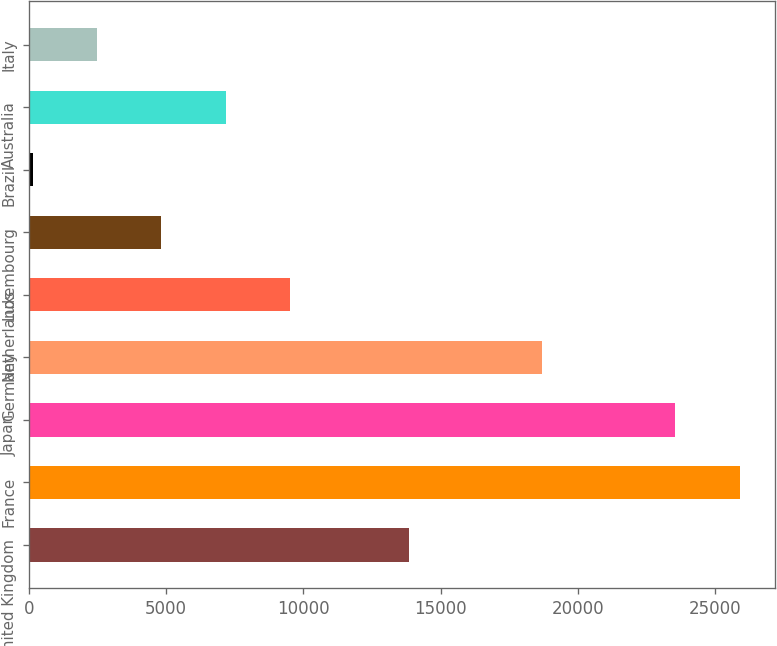<chart> <loc_0><loc_0><loc_500><loc_500><bar_chart><fcel>United Kingdom<fcel>France<fcel>Japan<fcel>Germany<fcel>Netherlands<fcel>Luxembourg<fcel>Brazil<fcel>Australia<fcel>Italy<nl><fcel>13852<fcel>25883.2<fcel>23542<fcel>18674<fcel>9513.8<fcel>4831.4<fcel>149<fcel>7172.6<fcel>2490.2<nl></chart> 